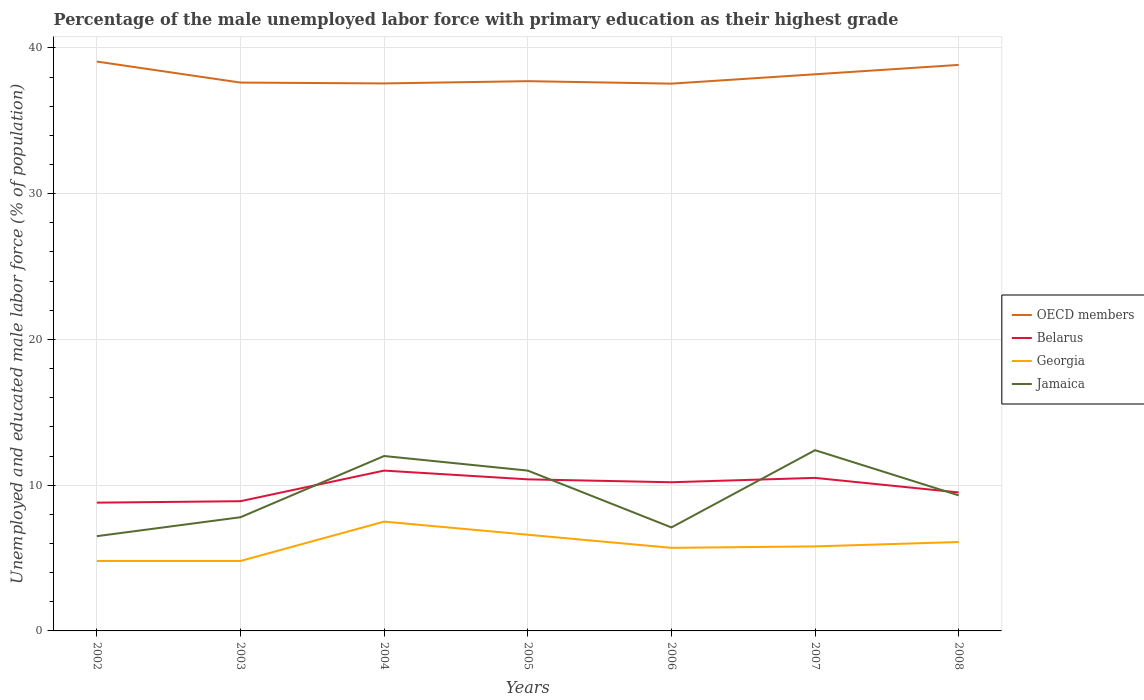How many different coloured lines are there?
Make the answer very short. 4. Across all years, what is the maximum percentage of the unemployed male labor force with primary education in Georgia?
Your response must be concise. 4.8. What is the total percentage of the unemployed male labor force with primary education in Georgia in the graph?
Your answer should be compact. -0.9. What is the difference between the highest and the second highest percentage of the unemployed male labor force with primary education in Georgia?
Provide a succinct answer. 2.7. What is the difference between the highest and the lowest percentage of the unemployed male labor force with primary education in Jamaica?
Provide a short and direct response. 3. Is the percentage of the unemployed male labor force with primary education in Jamaica strictly greater than the percentage of the unemployed male labor force with primary education in Georgia over the years?
Give a very brief answer. No. How many lines are there?
Your answer should be compact. 4. Are the values on the major ticks of Y-axis written in scientific E-notation?
Offer a terse response. No. Does the graph contain grids?
Provide a succinct answer. Yes. How many legend labels are there?
Make the answer very short. 4. How are the legend labels stacked?
Offer a terse response. Vertical. What is the title of the graph?
Ensure brevity in your answer.  Percentage of the male unemployed labor force with primary education as their highest grade. What is the label or title of the Y-axis?
Ensure brevity in your answer.  Unemployed and educated male labor force (% of population). What is the Unemployed and educated male labor force (% of population) in OECD members in 2002?
Provide a succinct answer. 39.06. What is the Unemployed and educated male labor force (% of population) in Belarus in 2002?
Offer a very short reply. 8.8. What is the Unemployed and educated male labor force (% of population) of Georgia in 2002?
Offer a very short reply. 4.8. What is the Unemployed and educated male labor force (% of population) in OECD members in 2003?
Your answer should be compact. 37.62. What is the Unemployed and educated male labor force (% of population) in Belarus in 2003?
Offer a terse response. 8.9. What is the Unemployed and educated male labor force (% of population) of Georgia in 2003?
Give a very brief answer. 4.8. What is the Unemployed and educated male labor force (% of population) in Jamaica in 2003?
Keep it short and to the point. 7.8. What is the Unemployed and educated male labor force (% of population) in OECD members in 2004?
Give a very brief answer. 37.56. What is the Unemployed and educated male labor force (% of population) of Jamaica in 2004?
Offer a terse response. 12. What is the Unemployed and educated male labor force (% of population) of OECD members in 2005?
Your response must be concise. 37.72. What is the Unemployed and educated male labor force (% of population) of Belarus in 2005?
Provide a short and direct response. 10.4. What is the Unemployed and educated male labor force (% of population) of Georgia in 2005?
Keep it short and to the point. 6.6. What is the Unemployed and educated male labor force (% of population) in Jamaica in 2005?
Give a very brief answer. 11. What is the Unemployed and educated male labor force (% of population) of OECD members in 2006?
Make the answer very short. 37.55. What is the Unemployed and educated male labor force (% of population) in Belarus in 2006?
Your response must be concise. 10.2. What is the Unemployed and educated male labor force (% of population) in Georgia in 2006?
Ensure brevity in your answer.  5.7. What is the Unemployed and educated male labor force (% of population) in Jamaica in 2006?
Give a very brief answer. 7.1. What is the Unemployed and educated male labor force (% of population) of OECD members in 2007?
Your answer should be very brief. 38.19. What is the Unemployed and educated male labor force (% of population) in Georgia in 2007?
Your answer should be compact. 5.8. What is the Unemployed and educated male labor force (% of population) in Jamaica in 2007?
Provide a succinct answer. 12.4. What is the Unemployed and educated male labor force (% of population) in OECD members in 2008?
Offer a terse response. 38.83. What is the Unemployed and educated male labor force (% of population) of Belarus in 2008?
Provide a short and direct response. 9.5. What is the Unemployed and educated male labor force (% of population) in Georgia in 2008?
Ensure brevity in your answer.  6.1. What is the Unemployed and educated male labor force (% of population) of Jamaica in 2008?
Your response must be concise. 9.3. Across all years, what is the maximum Unemployed and educated male labor force (% of population) in OECD members?
Ensure brevity in your answer.  39.06. Across all years, what is the maximum Unemployed and educated male labor force (% of population) in Belarus?
Provide a short and direct response. 11. Across all years, what is the maximum Unemployed and educated male labor force (% of population) of Jamaica?
Keep it short and to the point. 12.4. Across all years, what is the minimum Unemployed and educated male labor force (% of population) in OECD members?
Provide a short and direct response. 37.55. Across all years, what is the minimum Unemployed and educated male labor force (% of population) in Belarus?
Give a very brief answer. 8.8. Across all years, what is the minimum Unemployed and educated male labor force (% of population) of Georgia?
Ensure brevity in your answer.  4.8. Across all years, what is the minimum Unemployed and educated male labor force (% of population) in Jamaica?
Provide a short and direct response. 6.5. What is the total Unemployed and educated male labor force (% of population) in OECD members in the graph?
Offer a terse response. 266.54. What is the total Unemployed and educated male labor force (% of population) of Belarus in the graph?
Give a very brief answer. 69.3. What is the total Unemployed and educated male labor force (% of population) of Georgia in the graph?
Ensure brevity in your answer.  41.3. What is the total Unemployed and educated male labor force (% of population) of Jamaica in the graph?
Make the answer very short. 66.1. What is the difference between the Unemployed and educated male labor force (% of population) in OECD members in 2002 and that in 2003?
Give a very brief answer. 1.44. What is the difference between the Unemployed and educated male labor force (% of population) in Belarus in 2002 and that in 2003?
Make the answer very short. -0.1. What is the difference between the Unemployed and educated male labor force (% of population) of Jamaica in 2002 and that in 2003?
Provide a succinct answer. -1.3. What is the difference between the Unemployed and educated male labor force (% of population) in OECD members in 2002 and that in 2004?
Offer a very short reply. 1.5. What is the difference between the Unemployed and educated male labor force (% of population) in Jamaica in 2002 and that in 2004?
Provide a succinct answer. -5.5. What is the difference between the Unemployed and educated male labor force (% of population) of OECD members in 2002 and that in 2005?
Ensure brevity in your answer.  1.35. What is the difference between the Unemployed and educated male labor force (% of population) in Belarus in 2002 and that in 2005?
Keep it short and to the point. -1.6. What is the difference between the Unemployed and educated male labor force (% of population) in OECD members in 2002 and that in 2006?
Give a very brief answer. 1.52. What is the difference between the Unemployed and educated male labor force (% of population) in OECD members in 2002 and that in 2007?
Your response must be concise. 0.87. What is the difference between the Unemployed and educated male labor force (% of population) of OECD members in 2002 and that in 2008?
Provide a short and direct response. 0.23. What is the difference between the Unemployed and educated male labor force (% of population) in Georgia in 2002 and that in 2008?
Offer a terse response. -1.3. What is the difference between the Unemployed and educated male labor force (% of population) in Jamaica in 2002 and that in 2008?
Your answer should be very brief. -2.8. What is the difference between the Unemployed and educated male labor force (% of population) in OECD members in 2003 and that in 2004?
Provide a succinct answer. 0.06. What is the difference between the Unemployed and educated male labor force (% of population) in Georgia in 2003 and that in 2004?
Your response must be concise. -2.7. What is the difference between the Unemployed and educated male labor force (% of population) in Jamaica in 2003 and that in 2004?
Keep it short and to the point. -4.2. What is the difference between the Unemployed and educated male labor force (% of population) of OECD members in 2003 and that in 2005?
Offer a very short reply. -0.1. What is the difference between the Unemployed and educated male labor force (% of population) of Georgia in 2003 and that in 2005?
Your answer should be compact. -1.8. What is the difference between the Unemployed and educated male labor force (% of population) in Jamaica in 2003 and that in 2005?
Provide a short and direct response. -3.2. What is the difference between the Unemployed and educated male labor force (% of population) of OECD members in 2003 and that in 2006?
Your response must be concise. 0.07. What is the difference between the Unemployed and educated male labor force (% of population) of Jamaica in 2003 and that in 2006?
Offer a terse response. 0.7. What is the difference between the Unemployed and educated male labor force (% of population) in OECD members in 2003 and that in 2007?
Provide a short and direct response. -0.57. What is the difference between the Unemployed and educated male labor force (% of population) in Belarus in 2003 and that in 2007?
Your response must be concise. -1.6. What is the difference between the Unemployed and educated male labor force (% of population) in Jamaica in 2003 and that in 2007?
Make the answer very short. -4.6. What is the difference between the Unemployed and educated male labor force (% of population) in OECD members in 2003 and that in 2008?
Offer a very short reply. -1.21. What is the difference between the Unemployed and educated male labor force (% of population) in Belarus in 2003 and that in 2008?
Your response must be concise. -0.6. What is the difference between the Unemployed and educated male labor force (% of population) in Georgia in 2003 and that in 2008?
Offer a very short reply. -1.3. What is the difference between the Unemployed and educated male labor force (% of population) of Jamaica in 2003 and that in 2008?
Provide a succinct answer. -1.5. What is the difference between the Unemployed and educated male labor force (% of population) in OECD members in 2004 and that in 2005?
Keep it short and to the point. -0.16. What is the difference between the Unemployed and educated male labor force (% of population) of Belarus in 2004 and that in 2005?
Give a very brief answer. 0.6. What is the difference between the Unemployed and educated male labor force (% of population) in Georgia in 2004 and that in 2005?
Give a very brief answer. 0.9. What is the difference between the Unemployed and educated male labor force (% of population) in Jamaica in 2004 and that in 2005?
Your response must be concise. 1. What is the difference between the Unemployed and educated male labor force (% of population) in OECD members in 2004 and that in 2006?
Your answer should be very brief. 0.02. What is the difference between the Unemployed and educated male labor force (% of population) in Belarus in 2004 and that in 2006?
Your response must be concise. 0.8. What is the difference between the Unemployed and educated male labor force (% of population) of Georgia in 2004 and that in 2006?
Provide a succinct answer. 1.8. What is the difference between the Unemployed and educated male labor force (% of population) of Jamaica in 2004 and that in 2006?
Make the answer very short. 4.9. What is the difference between the Unemployed and educated male labor force (% of population) in OECD members in 2004 and that in 2007?
Offer a very short reply. -0.63. What is the difference between the Unemployed and educated male labor force (% of population) in Belarus in 2004 and that in 2007?
Give a very brief answer. 0.5. What is the difference between the Unemployed and educated male labor force (% of population) in Jamaica in 2004 and that in 2007?
Offer a terse response. -0.4. What is the difference between the Unemployed and educated male labor force (% of population) of OECD members in 2004 and that in 2008?
Offer a terse response. -1.27. What is the difference between the Unemployed and educated male labor force (% of population) of Belarus in 2004 and that in 2008?
Give a very brief answer. 1.5. What is the difference between the Unemployed and educated male labor force (% of population) of Georgia in 2004 and that in 2008?
Provide a succinct answer. 1.4. What is the difference between the Unemployed and educated male labor force (% of population) of Jamaica in 2004 and that in 2008?
Make the answer very short. 2.7. What is the difference between the Unemployed and educated male labor force (% of population) of OECD members in 2005 and that in 2006?
Keep it short and to the point. 0.17. What is the difference between the Unemployed and educated male labor force (% of population) of Jamaica in 2005 and that in 2006?
Offer a very short reply. 3.9. What is the difference between the Unemployed and educated male labor force (% of population) in OECD members in 2005 and that in 2007?
Provide a succinct answer. -0.47. What is the difference between the Unemployed and educated male labor force (% of population) of Belarus in 2005 and that in 2007?
Ensure brevity in your answer.  -0.1. What is the difference between the Unemployed and educated male labor force (% of population) in Georgia in 2005 and that in 2007?
Your answer should be very brief. 0.8. What is the difference between the Unemployed and educated male labor force (% of population) of OECD members in 2005 and that in 2008?
Your answer should be compact. -1.12. What is the difference between the Unemployed and educated male labor force (% of population) in Belarus in 2005 and that in 2008?
Give a very brief answer. 0.9. What is the difference between the Unemployed and educated male labor force (% of population) in Georgia in 2005 and that in 2008?
Offer a terse response. 0.5. What is the difference between the Unemployed and educated male labor force (% of population) in Jamaica in 2005 and that in 2008?
Give a very brief answer. 1.7. What is the difference between the Unemployed and educated male labor force (% of population) of OECD members in 2006 and that in 2007?
Offer a terse response. -0.64. What is the difference between the Unemployed and educated male labor force (% of population) of Belarus in 2006 and that in 2007?
Offer a terse response. -0.3. What is the difference between the Unemployed and educated male labor force (% of population) in Georgia in 2006 and that in 2007?
Your response must be concise. -0.1. What is the difference between the Unemployed and educated male labor force (% of population) of OECD members in 2006 and that in 2008?
Offer a very short reply. -1.29. What is the difference between the Unemployed and educated male labor force (% of population) of OECD members in 2007 and that in 2008?
Provide a succinct answer. -0.64. What is the difference between the Unemployed and educated male labor force (% of population) in Jamaica in 2007 and that in 2008?
Your answer should be compact. 3.1. What is the difference between the Unemployed and educated male labor force (% of population) of OECD members in 2002 and the Unemployed and educated male labor force (% of population) of Belarus in 2003?
Keep it short and to the point. 30.16. What is the difference between the Unemployed and educated male labor force (% of population) in OECD members in 2002 and the Unemployed and educated male labor force (% of population) in Georgia in 2003?
Give a very brief answer. 34.26. What is the difference between the Unemployed and educated male labor force (% of population) of OECD members in 2002 and the Unemployed and educated male labor force (% of population) of Jamaica in 2003?
Your answer should be very brief. 31.26. What is the difference between the Unemployed and educated male labor force (% of population) in Belarus in 2002 and the Unemployed and educated male labor force (% of population) in Jamaica in 2003?
Offer a terse response. 1. What is the difference between the Unemployed and educated male labor force (% of population) of OECD members in 2002 and the Unemployed and educated male labor force (% of population) of Belarus in 2004?
Offer a very short reply. 28.06. What is the difference between the Unemployed and educated male labor force (% of population) in OECD members in 2002 and the Unemployed and educated male labor force (% of population) in Georgia in 2004?
Your response must be concise. 31.56. What is the difference between the Unemployed and educated male labor force (% of population) in OECD members in 2002 and the Unemployed and educated male labor force (% of population) in Jamaica in 2004?
Your answer should be very brief. 27.06. What is the difference between the Unemployed and educated male labor force (% of population) of Belarus in 2002 and the Unemployed and educated male labor force (% of population) of Jamaica in 2004?
Your answer should be very brief. -3.2. What is the difference between the Unemployed and educated male labor force (% of population) in Georgia in 2002 and the Unemployed and educated male labor force (% of population) in Jamaica in 2004?
Your answer should be very brief. -7.2. What is the difference between the Unemployed and educated male labor force (% of population) in OECD members in 2002 and the Unemployed and educated male labor force (% of population) in Belarus in 2005?
Your answer should be compact. 28.66. What is the difference between the Unemployed and educated male labor force (% of population) in OECD members in 2002 and the Unemployed and educated male labor force (% of population) in Georgia in 2005?
Offer a very short reply. 32.46. What is the difference between the Unemployed and educated male labor force (% of population) of OECD members in 2002 and the Unemployed and educated male labor force (% of population) of Jamaica in 2005?
Give a very brief answer. 28.06. What is the difference between the Unemployed and educated male labor force (% of population) in Georgia in 2002 and the Unemployed and educated male labor force (% of population) in Jamaica in 2005?
Your answer should be very brief. -6.2. What is the difference between the Unemployed and educated male labor force (% of population) in OECD members in 2002 and the Unemployed and educated male labor force (% of population) in Belarus in 2006?
Your answer should be compact. 28.86. What is the difference between the Unemployed and educated male labor force (% of population) of OECD members in 2002 and the Unemployed and educated male labor force (% of population) of Georgia in 2006?
Make the answer very short. 33.36. What is the difference between the Unemployed and educated male labor force (% of population) in OECD members in 2002 and the Unemployed and educated male labor force (% of population) in Jamaica in 2006?
Your response must be concise. 31.96. What is the difference between the Unemployed and educated male labor force (% of population) in OECD members in 2002 and the Unemployed and educated male labor force (% of population) in Belarus in 2007?
Your answer should be compact. 28.56. What is the difference between the Unemployed and educated male labor force (% of population) in OECD members in 2002 and the Unemployed and educated male labor force (% of population) in Georgia in 2007?
Give a very brief answer. 33.26. What is the difference between the Unemployed and educated male labor force (% of population) of OECD members in 2002 and the Unemployed and educated male labor force (% of population) of Jamaica in 2007?
Keep it short and to the point. 26.66. What is the difference between the Unemployed and educated male labor force (% of population) of Georgia in 2002 and the Unemployed and educated male labor force (% of population) of Jamaica in 2007?
Offer a very short reply. -7.6. What is the difference between the Unemployed and educated male labor force (% of population) of OECD members in 2002 and the Unemployed and educated male labor force (% of population) of Belarus in 2008?
Offer a very short reply. 29.56. What is the difference between the Unemployed and educated male labor force (% of population) in OECD members in 2002 and the Unemployed and educated male labor force (% of population) in Georgia in 2008?
Ensure brevity in your answer.  32.96. What is the difference between the Unemployed and educated male labor force (% of population) in OECD members in 2002 and the Unemployed and educated male labor force (% of population) in Jamaica in 2008?
Your answer should be very brief. 29.76. What is the difference between the Unemployed and educated male labor force (% of population) of Georgia in 2002 and the Unemployed and educated male labor force (% of population) of Jamaica in 2008?
Your response must be concise. -4.5. What is the difference between the Unemployed and educated male labor force (% of population) in OECD members in 2003 and the Unemployed and educated male labor force (% of population) in Belarus in 2004?
Make the answer very short. 26.62. What is the difference between the Unemployed and educated male labor force (% of population) in OECD members in 2003 and the Unemployed and educated male labor force (% of population) in Georgia in 2004?
Your response must be concise. 30.12. What is the difference between the Unemployed and educated male labor force (% of population) in OECD members in 2003 and the Unemployed and educated male labor force (% of population) in Jamaica in 2004?
Ensure brevity in your answer.  25.62. What is the difference between the Unemployed and educated male labor force (% of population) in Belarus in 2003 and the Unemployed and educated male labor force (% of population) in Georgia in 2004?
Ensure brevity in your answer.  1.4. What is the difference between the Unemployed and educated male labor force (% of population) in Georgia in 2003 and the Unemployed and educated male labor force (% of population) in Jamaica in 2004?
Keep it short and to the point. -7.2. What is the difference between the Unemployed and educated male labor force (% of population) in OECD members in 2003 and the Unemployed and educated male labor force (% of population) in Belarus in 2005?
Give a very brief answer. 27.22. What is the difference between the Unemployed and educated male labor force (% of population) in OECD members in 2003 and the Unemployed and educated male labor force (% of population) in Georgia in 2005?
Give a very brief answer. 31.02. What is the difference between the Unemployed and educated male labor force (% of population) of OECD members in 2003 and the Unemployed and educated male labor force (% of population) of Jamaica in 2005?
Provide a short and direct response. 26.62. What is the difference between the Unemployed and educated male labor force (% of population) in Belarus in 2003 and the Unemployed and educated male labor force (% of population) in Jamaica in 2005?
Make the answer very short. -2.1. What is the difference between the Unemployed and educated male labor force (% of population) in OECD members in 2003 and the Unemployed and educated male labor force (% of population) in Belarus in 2006?
Offer a very short reply. 27.42. What is the difference between the Unemployed and educated male labor force (% of population) in OECD members in 2003 and the Unemployed and educated male labor force (% of population) in Georgia in 2006?
Make the answer very short. 31.92. What is the difference between the Unemployed and educated male labor force (% of population) in OECD members in 2003 and the Unemployed and educated male labor force (% of population) in Jamaica in 2006?
Provide a succinct answer. 30.52. What is the difference between the Unemployed and educated male labor force (% of population) in Belarus in 2003 and the Unemployed and educated male labor force (% of population) in Georgia in 2006?
Keep it short and to the point. 3.2. What is the difference between the Unemployed and educated male labor force (% of population) of Georgia in 2003 and the Unemployed and educated male labor force (% of population) of Jamaica in 2006?
Keep it short and to the point. -2.3. What is the difference between the Unemployed and educated male labor force (% of population) in OECD members in 2003 and the Unemployed and educated male labor force (% of population) in Belarus in 2007?
Give a very brief answer. 27.12. What is the difference between the Unemployed and educated male labor force (% of population) in OECD members in 2003 and the Unemployed and educated male labor force (% of population) in Georgia in 2007?
Your response must be concise. 31.82. What is the difference between the Unemployed and educated male labor force (% of population) in OECD members in 2003 and the Unemployed and educated male labor force (% of population) in Jamaica in 2007?
Your response must be concise. 25.22. What is the difference between the Unemployed and educated male labor force (% of population) of Belarus in 2003 and the Unemployed and educated male labor force (% of population) of Georgia in 2007?
Provide a succinct answer. 3.1. What is the difference between the Unemployed and educated male labor force (% of population) in Belarus in 2003 and the Unemployed and educated male labor force (% of population) in Jamaica in 2007?
Offer a terse response. -3.5. What is the difference between the Unemployed and educated male labor force (% of population) of Georgia in 2003 and the Unemployed and educated male labor force (% of population) of Jamaica in 2007?
Provide a succinct answer. -7.6. What is the difference between the Unemployed and educated male labor force (% of population) in OECD members in 2003 and the Unemployed and educated male labor force (% of population) in Belarus in 2008?
Provide a short and direct response. 28.12. What is the difference between the Unemployed and educated male labor force (% of population) in OECD members in 2003 and the Unemployed and educated male labor force (% of population) in Georgia in 2008?
Make the answer very short. 31.52. What is the difference between the Unemployed and educated male labor force (% of population) of OECD members in 2003 and the Unemployed and educated male labor force (% of population) of Jamaica in 2008?
Offer a terse response. 28.32. What is the difference between the Unemployed and educated male labor force (% of population) of Georgia in 2003 and the Unemployed and educated male labor force (% of population) of Jamaica in 2008?
Provide a succinct answer. -4.5. What is the difference between the Unemployed and educated male labor force (% of population) of OECD members in 2004 and the Unemployed and educated male labor force (% of population) of Belarus in 2005?
Your answer should be compact. 27.16. What is the difference between the Unemployed and educated male labor force (% of population) in OECD members in 2004 and the Unemployed and educated male labor force (% of population) in Georgia in 2005?
Your answer should be very brief. 30.96. What is the difference between the Unemployed and educated male labor force (% of population) of OECD members in 2004 and the Unemployed and educated male labor force (% of population) of Jamaica in 2005?
Keep it short and to the point. 26.56. What is the difference between the Unemployed and educated male labor force (% of population) of OECD members in 2004 and the Unemployed and educated male labor force (% of population) of Belarus in 2006?
Your answer should be compact. 27.36. What is the difference between the Unemployed and educated male labor force (% of population) of OECD members in 2004 and the Unemployed and educated male labor force (% of population) of Georgia in 2006?
Provide a short and direct response. 31.86. What is the difference between the Unemployed and educated male labor force (% of population) of OECD members in 2004 and the Unemployed and educated male labor force (% of population) of Jamaica in 2006?
Ensure brevity in your answer.  30.46. What is the difference between the Unemployed and educated male labor force (% of population) of Belarus in 2004 and the Unemployed and educated male labor force (% of population) of Jamaica in 2006?
Make the answer very short. 3.9. What is the difference between the Unemployed and educated male labor force (% of population) of Georgia in 2004 and the Unemployed and educated male labor force (% of population) of Jamaica in 2006?
Keep it short and to the point. 0.4. What is the difference between the Unemployed and educated male labor force (% of population) of OECD members in 2004 and the Unemployed and educated male labor force (% of population) of Belarus in 2007?
Make the answer very short. 27.06. What is the difference between the Unemployed and educated male labor force (% of population) of OECD members in 2004 and the Unemployed and educated male labor force (% of population) of Georgia in 2007?
Ensure brevity in your answer.  31.76. What is the difference between the Unemployed and educated male labor force (% of population) of OECD members in 2004 and the Unemployed and educated male labor force (% of population) of Jamaica in 2007?
Provide a succinct answer. 25.16. What is the difference between the Unemployed and educated male labor force (% of population) in OECD members in 2004 and the Unemployed and educated male labor force (% of population) in Belarus in 2008?
Offer a very short reply. 28.06. What is the difference between the Unemployed and educated male labor force (% of population) in OECD members in 2004 and the Unemployed and educated male labor force (% of population) in Georgia in 2008?
Offer a terse response. 31.46. What is the difference between the Unemployed and educated male labor force (% of population) of OECD members in 2004 and the Unemployed and educated male labor force (% of population) of Jamaica in 2008?
Provide a succinct answer. 28.26. What is the difference between the Unemployed and educated male labor force (% of population) in Belarus in 2004 and the Unemployed and educated male labor force (% of population) in Jamaica in 2008?
Your response must be concise. 1.7. What is the difference between the Unemployed and educated male labor force (% of population) of Georgia in 2004 and the Unemployed and educated male labor force (% of population) of Jamaica in 2008?
Give a very brief answer. -1.8. What is the difference between the Unemployed and educated male labor force (% of population) in OECD members in 2005 and the Unemployed and educated male labor force (% of population) in Belarus in 2006?
Provide a short and direct response. 27.52. What is the difference between the Unemployed and educated male labor force (% of population) of OECD members in 2005 and the Unemployed and educated male labor force (% of population) of Georgia in 2006?
Provide a succinct answer. 32.02. What is the difference between the Unemployed and educated male labor force (% of population) in OECD members in 2005 and the Unemployed and educated male labor force (% of population) in Jamaica in 2006?
Make the answer very short. 30.62. What is the difference between the Unemployed and educated male labor force (% of population) of Belarus in 2005 and the Unemployed and educated male labor force (% of population) of Georgia in 2006?
Your answer should be very brief. 4.7. What is the difference between the Unemployed and educated male labor force (% of population) in Belarus in 2005 and the Unemployed and educated male labor force (% of population) in Jamaica in 2006?
Keep it short and to the point. 3.3. What is the difference between the Unemployed and educated male labor force (% of population) of Georgia in 2005 and the Unemployed and educated male labor force (% of population) of Jamaica in 2006?
Offer a very short reply. -0.5. What is the difference between the Unemployed and educated male labor force (% of population) of OECD members in 2005 and the Unemployed and educated male labor force (% of population) of Belarus in 2007?
Your response must be concise. 27.22. What is the difference between the Unemployed and educated male labor force (% of population) of OECD members in 2005 and the Unemployed and educated male labor force (% of population) of Georgia in 2007?
Offer a very short reply. 31.92. What is the difference between the Unemployed and educated male labor force (% of population) of OECD members in 2005 and the Unemployed and educated male labor force (% of population) of Jamaica in 2007?
Keep it short and to the point. 25.32. What is the difference between the Unemployed and educated male labor force (% of population) in OECD members in 2005 and the Unemployed and educated male labor force (% of population) in Belarus in 2008?
Provide a succinct answer. 28.22. What is the difference between the Unemployed and educated male labor force (% of population) of OECD members in 2005 and the Unemployed and educated male labor force (% of population) of Georgia in 2008?
Offer a terse response. 31.62. What is the difference between the Unemployed and educated male labor force (% of population) of OECD members in 2005 and the Unemployed and educated male labor force (% of population) of Jamaica in 2008?
Make the answer very short. 28.42. What is the difference between the Unemployed and educated male labor force (% of population) in Belarus in 2005 and the Unemployed and educated male labor force (% of population) in Jamaica in 2008?
Ensure brevity in your answer.  1.1. What is the difference between the Unemployed and educated male labor force (% of population) in OECD members in 2006 and the Unemployed and educated male labor force (% of population) in Belarus in 2007?
Provide a succinct answer. 27.05. What is the difference between the Unemployed and educated male labor force (% of population) in OECD members in 2006 and the Unemployed and educated male labor force (% of population) in Georgia in 2007?
Give a very brief answer. 31.75. What is the difference between the Unemployed and educated male labor force (% of population) of OECD members in 2006 and the Unemployed and educated male labor force (% of population) of Jamaica in 2007?
Give a very brief answer. 25.15. What is the difference between the Unemployed and educated male labor force (% of population) of Georgia in 2006 and the Unemployed and educated male labor force (% of population) of Jamaica in 2007?
Make the answer very short. -6.7. What is the difference between the Unemployed and educated male labor force (% of population) of OECD members in 2006 and the Unemployed and educated male labor force (% of population) of Belarus in 2008?
Offer a very short reply. 28.05. What is the difference between the Unemployed and educated male labor force (% of population) of OECD members in 2006 and the Unemployed and educated male labor force (% of population) of Georgia in 2008?
Your answer should be very brief. 31.45. What is the difference between the Unemployed and educated male labor force (% of population) in OECD members in 2006 and the Unemployed and educated male labor force (% of population) in Jamaica in 2008?
Your answer should be compact. 28.25. What is the difference between the Unemployed and educated male labor force (% of population) in Belarus in 2006 and the Unemployed and educated male labor force (% of population) in Jamaica in 2008?
Ensure brevity in your answer.  0.9. What is the difference between the Unemployed and educated male labor force (% of population) in OECD members in 2007 and the Unemployed and educated male labor force (% of population) in Belarus in 2008?
Make the answer very short. 28.69. What is the difference between the Unemployed and educated male labor force (% of population) of OECD members in 2007 and the Unemployed and educated male labor force (% of population) of Georgia in 2008?
Ensure brevity in your answer.  32.09. What is the difference between the Unemployed and educated male labor force (% of population) in OECD members in 2007 and the Unemployed and educated male labor force (% of population) in Jamaica in 2008?
Make the answer very short. 28.89. What is the difference between the Unemployed and educated male labor force (% of population) in Belarus in 2007 and the Unemployed and educated male labor force (% of population) in Jamaica in 2008?
Your response must be concise. 1.2. What is the average Unemployed and educated male labor force (% of population) of OECD members per year?
Give a very brief answer. 38.08. What is the average Unemployed and educated male labor force (% of population) of Georgia per year?
Ensure brevity in your answer.  5.9. What is the average Unemployed and educated male labor force (% of population) of Jamaica per year?
Provide a short and direct response. 9.44. In the year 2002, what is the difference between the Unemployed and educated male labor force (% of population) of OECD members and Unemployed and educated male labor force (% of population) of Belarus?
Offer a terse response. 30.26. In the year 2002, what is the difference between the Unemployed and educated male labor force (% of population) in OECD members and Unemployed and educated male labor force (% of population) in Georgia?
Offer a very short reply. 34.26. In the year 2002, what is the difference between the Unemployed and educated male labor force (% of population) of OECD members and Unemployed and educated male labor force (% of population) of Jamaica?
Make the answer very short. 32.56. In the year 2003, what is the difference between the Unemployed and educated male labor force (% of population) of OECD members and Unemployed and educated male labor force (% of population) of Belarus?
Provide a succinct answer. 28.72. In the year 2003, what is the difference between the Unemployed and educated male labor force (% of population) in OECD members and Unemployed and educated male labor force (% of population) in Georgia?
Provide a short and direct response. 32.82. In the year 2003, what is the difference between the Unemployed and educated male labor force (% of population) of OECD members and Unemployed and educated male labor force (% of population) of Jamaica?
Offer a very short reply. 29.82. In the year 2004, what is the difference between the Unemployed and educated male labor force (% of population) in OECD members and Unemployed and educated male labor force (% of population) in Belarus?
Provide a short and direct response. 26.56. In the year 2004, what is the difference between the Unemployed and educated male labor force (% of population) in OECD members and Unemployed and educated male labor force (% of population) in Georgia?
Make the answer very short. 30.06. In the year 2004, what is the difference between the Unemployed and educated male labor force (% of population) of OECD members and Unemployed and educated male labor force (% of population) of Jamaica?
Ensure brevity in your answer.  25.56. In the year 2004, what is the difference between the Unemployed and educated male labor force (% of population) of Belarus and Unemployed and educated male labor force (% of population) of Georgia?
Ensure brevity in your answer.  3.5. In the year 2004, what is the difference between the Unemployed and educated male labor force (% of population) of Belarus and Unemployed and educated male labor force (% of population) of Jamaica?
Make the answer very short. -1. In the year 2004, what is the difference between the Unemployed and educated male labor force (% of population) in Georgia and Unemployed and educated male labor force (% of population) in Jamaica?
Your response must be concise. -4.5. In the year 2005, what is the difference between the Unemployed and educated male labor force (% of population) in OECD members and Unemployed and educated male labor force (% of population) in Belarus?
Provide a short and direct response. 27.32. In the year 2005, what is the difference between the Unemployed and educated male labor force (% of population) of OECD members and Unemployed and educated male labor force (% of population) of Georgia?
Give a very brief answer. 31.12. In the year 2005, what is the difference between the Unemployed and educated male labor force (% of population) of OECD members and Unemployed and educated male labor force (% of population) of Jamaica?
Ensure brevity in your answer.  26.72. In the year 2005, what is the difference between the Unemployed and educated male labor force (% of population) in Belarus and Unemployed and educated male labor force (% of population) in Georgia?
Your answer should be very brief. 3.8. In the year 2006, what is the difference between the Unemployed and educated male labor force (% of population) in OECD members and Unemployed and educated male labor force (% of population) in Belarus?
Your answer should be very brief. 27.35. In the year 2006, what is the difference between the Unemployed and educated male labor force (% of population) of OECD members and Unemployed and educated male labor force (% of population) of Georgia?
Ensure brevity in your answer.  31.85. In the year 2006, what is the difference between the Unemployed and educated male labor force (% of population) of OECD members and Unemployed and educated male labor force (% of population) of Jamaica?
Your answer should be very brief. 30.45. In the year 2006, what is the difference between the Unemployed and educated male labor force (% of population) in Belarus and Unemployed and educated male labor force (% of population) in Jamaica?
Keep it short and to the point. 3.1. In the year 2007, what is the difference between the Unemployed and educated male labor force (% of population) in OECD members and Unemployed and educated male labor force (% of population) in Belarus?
Give a very brief answer. 27.69. In the year 2007, what is the difference between the Unemployed and educated male labor force (% of population) in OECD members and Unemployed and educated male labor force (% of population) in Georgia?
Provide a succinct answer. 32.39. In the year 2007, what is the difference between the Unemployed and educated male labor force (% of population) of OECD members and Unemployed and educated male labor force (% of population) of Jamaica?
Provide a short and direct response. 25.79. In the year 2007, what is the difference between the Unemployed and educated male labor force (% of population) of Belarus and Unemployed and educated male labor force (% of population) of Jamaica?
Your answer should be very brief. -1.9. In the year 2008, what is the difference between the Unemployed and educated male labor force (% of population) of OECD members and Unemployed and educated male labor force (% of population) of Belarus?
Offer a terse response. 29.33. In the year 2008, what is the difference between the Unemployed and educated male labor force (% of population) of OECD members and Unemployed and educated male labor force (% of population) of Georgia?
Keep it short and to the point. 32.73. In the year 2008, what is the difference between the Unemployed and educated male labor force (% of population) in OECD members and Unemployed and educated male labor force (% of population) in Jamaica?
Offer a very short reply. 29.53. In the year 2008, what is the difference between the Unemployed and educated male labor force (% of population) of Belarus and Unemployed and educated male labor force (% of population) of Georgia?
Provide a succinct answer. 3.4. In the year 2008, what is the difference between the Unemployed and educated male labor force (% of population) in Belarus and Unemployed and educated male labor force (% of population) in Jamaica?
Provide a short and direct response. 0.2. In the year 2008, what is the difference between the Unemployed and educated male labor force (% of population) in Georgia and Unemployed and educated male labor force (% of population) in Jamaica?
Make the answer very short. -3.2. What is the ratio of the Unemployed and educated male labor force (% of population) of OECD members in 2002 to that in 2003?
Your response must be concise. 1.04. What is the ratio of the Unemployed and educated male labor force (% of population) in Belarus in 2002 to that in 2003?
Give a very brief answer. 0.99. What is the ratio of the Unemployed and educated male labor force (% of population) of OECD members in 2002 to that in 2004?
Offer a terse response. 1.04. What is the ratio of the Unemployed and educated male labor force (% of population) in Belarus in 2002 to that in 2004?
Give a very brief answer. 0.8. What is the ratio of the Unemployed and educated male labor force (% of population) of Georgia in 2002 to that in 2004?
Your answer should be very brief. 0.64. What is the ratio of the Unemployed and educated male labor force (% of population) of Jamaica in 2002 to that in 2004?
Your answer should be compact. 0.54. What is the ratio of the Unemployed and educated male labor force (% of population) of OECD members in 2002 to that in 2005?
Your answer should be compact. 1.04. What is the ratio of the Unemployed and educated male labor force (% of population) in Belarus in 2002 to that in 2005?
Provide a succinct answer. 0.85. What is the ratio of the Unemployed and educated male labor force (% of population) of Georgia in 2002 to that in 2005?
Your response must be concise. 0.73. What is the ratio of the Unemployed and educated male labor force (% of population) of Jamaica in 2002 to that in 2005?
Give a very brief answer. 0.59. What is the ratio of the Unemployed and educated male labor force (% of population) in OECD members in 2002 to that in 2006?
Your answer should be compact. 1.04. What is the ratio of the Unemployed and educated male labor force (% of population) in Belarus in 2002 to that in 2006?
Make the answer very short. 0.86. What is the ratio of the Unemployed and educated male labor force (% of population) in Georgia in 2002 to that in 2006?
Make the answer very short. 0.84. What is the ratio of the Unemployed and educated male labor force (% of population) of Jamaica in 2002 to that in 2006?
Provide a succinct answer. 0.92. What is the ratio of the Unemployed and educated male labor force (% of population) in OECD members in 2002 to that in 2007?
Provide a short and direct response. 1.02. What is the ratio of the Unemployed and educated male labor force (% of population) of Belarus in 2002 to that in 2007?
Keep it short and to the point. 0.84. What is the ratio of the Unemployed and educated male labor force (% of population) of Georgia in 2002 to that in 2007?
Give a very brief answer. 0.83. What is the ratio of the Unemployed and educated male labor force (% of population) of Jamaica in 2002 to that in 2007?
Ensure brevity in your answer.  0.52. What is the ratio of the Unemployed and educated male labor force (% of population) of OECD members in 2002 to that in 2008?
Your answer should be very brief. 1.01. What is the ratio of the Unemployed and educated male labor force (% of population) in Belarus in 2002 to that in 2008?
Your answer should be very brief. 0.93. What is the ratio of the Unemployed and educated male labor force (% of population) of Georgia in 2002 to that in 2008?
Your answer should be compact. 0.79. What is the ratio of the Unemployed and educated male labor force (% of population) of Jamaica in 2002 to that in 2008?
Your answer should be compact. 0.7. What is the ratio of the Unemployed and educated male labor force (% of population) of OECD members in 2003 to that in 2004?
Ensure brevity in your answer.  1. What is the ratio of the Unemployed and educated male labor force (% of population) of Belarus in 2003 to that in 2004?
Your response must be concise. 0.81. What is the ratio of the Unemployed and educated male labor force (% of population) of Georgia in 2003 to that in 2004?
Your answer should be compact. 0.64. What is the ratio of the Unemployed and educated male labor force (% of population) in Jamaica in 2003 to that in 2004?
Your answer should be very brief. 0.65. What is the ratio of the Unemployed and educated male labor force (% of population) of OECD members in 2003 to that in 2005?
Provide a succinct answer. 1. What is the ratio of the Unemployed and educated male labor force (% of population) of Belarus in 2003 to that in 2005?
Offer a terse response. 0.86. What is the ratio of the Unemployed and educated male labor force (% of population) of Georgia in 2003 to that in 2005?
Provide a succinct answer. 0.73. What is the ratio of the Unemployed and educated male labor force (% of population) of Jamaica in 2003 to that in 2005?
Your answer should be very brief. 0.71. What is the ratio of the Unemployed and educated male labor force (% of population) in Belarus in 2003 to that in 2006?
Offer a terse response. 0.87. What is the ratio of the Unemployed and educated male labor force (% of population) of Georgia in 2003 to that in 2006?
Keep it short and to the point. 0.84. What is the ratio of the Unemployed and educated male labor force (% of population) of Jamaica in 2003 to that in 2006?
Your answer should be very brief. 1.1. What is the ratio of the Unemployed and educated male labor force (% of population) of OECD members in 2003 to that in 2007?
Make the answer very short. 0.99. What is the ratio of the Unemployed and educated male labor force (% of population) of Belarus in 2003 to that in 2007?
Give a very brief answer. 0.85. What is the ratio of the Unemployed and educated male labor force (% of population) in Georgia in 2003 to that in 2007?
Your response must be concise. 0.83. What is the ratio of the Unemployed and educated male labor force (% of population) in Jamaica in 2003 to that in 2007?
Give a very brief answer. 0.63. What is the ratio of the Unemployed and educated male labor force (% of population) in OECD members in 2003 to that in 2008?
Keep it short and to the point. 0.97. What is the ratio of the Unemployed and educated male labor force (% of population) of Belarus in 2003 to that in 2008?
Ensure brevity in your answer.  0.94. What is the ratio of the Unemployed and educated male labor force (% of population) in Georgia in 2003 to that in 2008?
Your answer should be compact. 0.79. What is the ratio of the Unemployed and educated male labor force (% of population) in Jamaica in 2003 to that in 2008?
Your answer should be compact. 0.84. What is the ratio of the Unemployed and educated male labor force (% of population) of Belarus in 2004 to that in 2005?
Keep it short and to the point. 1.06. What is the ratio of the Unemployed and educated male labor force (% of population) in Georgia in 2004 to that in 2005?
Offer a terse response. 1.14. What is the ratio of the Unemployed and educated male labor force (% of population) of Jamaica in 2004 to that in 2005?
Your response must be concise. 1.09. What is the ratio of the Unemployed and educated male labor force (% of population) in Belarus in 2004 to that in 2006?
Ensure brevity in your answer.  1.08. What is the ratio of the Unemployed and educated male labor force (% of population) in Georgia in 2004 to that in 2006?
Your answer should be compact. 1.32. What is the ratio of the Unemployed and educated male labor force (% of population) of Jamaica in 2004 to that in 2006?
Provide a short and direct response. 1.69. What is the ratio of the Unemployed and educated male labor force (% of population) of OECD members in 2004 to that in 2007?
Your answer should be compact. 0.98. What is the ratio of the Unemployed and educated male labor force (% of population) of Belarus in 2004 to that in 2007?
Make the answer very short. 1.05. What is the ratio of the Unemployed and educated male labor force (% of population) of Georgia in 2004 to that in 2007?
Keep it short and to the point. 1.29. What is the ratio of the Unemployed and educated male labor force (% of population) of OECD members in 2004 to that in 2008?
Offer a very short reply. 0.97. What is the ratio of the Unemployed and educated male labor force (% of population) of Belarus in 2004 to that in 2008?
Ensure brevity in your answer.  1.16. What is the ratio of the Unemployed and educated male labor force (% of population) of Georgia in 2004 to that in 2008?
Provide a short and direct response. 1.23. What is the ratio of the Unemployed and educated male labor force (% of population) in Jamaica in 2004 to that in 2008?
Your answer should be compact. 1.29. What is the ratio of the Unemployed and educated male labor force (% of population) of Belarus in 2005 to that in 2006?
Your answer should be very brief. 1.02. What is the ratio of the Unemployed and educated male labor force (% of population) of Georgia in 2005 to that in 2006?
Offer a very short reply. 1.16. What is the ratio of the Unemployed and educated male labor force (% of population) in Jamaica in 2005 to that in 2006?
Offer a very short reply. 1.55. What is the ratio of the Unemployed and educated male labor force (% of population) in OECD members in 2005 to that in 2007?
Keep it short and to the point. 0.99. What is the ratio of the Unemployed and educated male labor force (% of population) in Belarus in 2005 to that in 2007?
Make the answer very short. 0.99. What is the ratio of the Unemployed and educated male labor force (% of population) in Georgia in 2005 to that in 2007?
Offer a very short reply. 1.14. What is the ratio of the Unemployed and educated male labor force (% of population) in Jamaica in 2005 to that in 2007?
Keep it short and to the point. 0.89. What is the ratio of the Unemployed and educated male labor force (% of population) of OECD members in 2005 to that in 2008?
Keep it short and to the point. 0.97. What is the ratio of the Unemployed and educated male labor force (% of population) of Belarus in 2005 to that in 2008?
Ensure brevity in your answer.  1.09. What is the ratio of the Unemployed and educated male labor force (% of population) in Georgia in 2005 to that in 2008?
Ensure brevity in your answer.  1.08. What is the ratio of the Unemployed and educated male labor force (% of population) of Jamaica in 2005 to that in 2008?
Your answer should be very brief. 1.18. What is the ratio of the Unemployed and educated male labor force (% of population) of OECD members in 2006 to that in 2007?
Make the answer very short. 0.98. What is the ratio of the Unemployed and educated male labor force (% of population) in Belarus in 2006 to that in 2007?
Provide a succinct answer. 0.97. What is the ratio of the Unemployed and educated male labor force (% of population) in Georgia in 2006 to that in 2007?
Ensure brevity in your answer.  0.98. What is the ratio of the Unemployed and educated male labor force (% of population) in Jamaica in 2006 to that in 2007?
Your answer should be compact. 0.57. What is the ratio of the Unemployed and educated male labor force (% of population) in OECD members in 2006 to that in 2008?
Your answer should be compact. 0.97. What is the ratio of the Unemployed and educated male labor force (% of population) of Belarus in 2006 to that in 2008?
Offer a very short reply. 1.07. What is the ratio of the Unemployed and educated male labor force (% of population) in Georgia in 2006 to that in 2008?
Give a very brief answer. 0.93. What is the ratio of the Unemployed and educated male labor force (% of population) in Jamaica in 2006 to that in 2008?
Ensure brevity in your answer.  0.76. What is the ratio of the Unemployed and educated male labor force (% of population) of OECD members in 2007 to that in 2008?
Provide a short and direct response. 0.98. What is the ratio of the Unemployed and educated male labor force (% of population) of Belarus in 2007 to that in 2008?
Give a very brief answer. 1.11. What is the ratio of the Unemployed and educated male labor force (% of population) in Georgia in 2007 to that in 2008?
Provide a succinct answer. 0.95. What is the ratio of the Unemployed and educated male labor force (% of population) in Jamaica in 2007 to that in 2008?
Provide a short and direct response. 1.33. What is the difference between the highest and the second highest Unemployed and educated male labor force (% of population) in OECD members?
Offer a terse response. 0.23. What is the difference between the highest and the second highest Unemployed and educated male labor force (% of population) in Belarus?
Your answer should be very brief. 0.5. What is the difference between the highest and the lowest Unemployed and educated male labor force (% of population) in OECD members?
Make the answer very short. 1.52. What is the difference between the highest and the lowest Unemployed and educated male labor force (% of population) of Jamaica?
Ensure brevity in your answer.  5.9. 